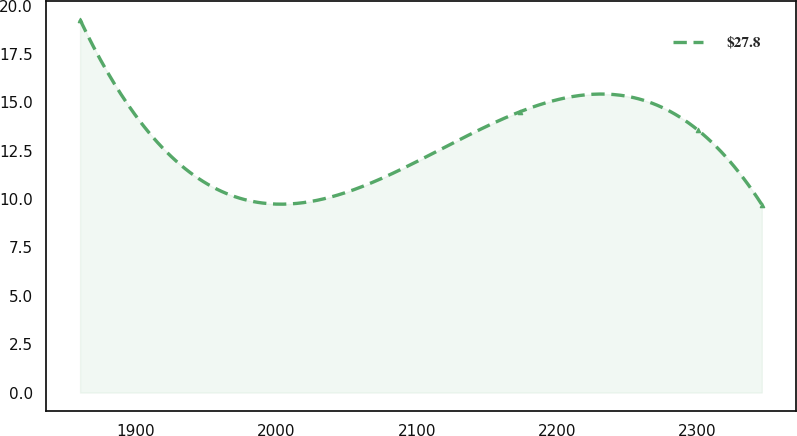<chart> <loc_0><loc_0><loc_500><loc_500><line_chart><ecel><fcel>$27.8<nl><fcel>1860.22<fcel>19.27<nl><fcel>2173.78<fcel>14.52<nl><fcel>2300.54<fcel>13.56<nl><fcel>2345.89<fcel>9.72<nl></chart> 